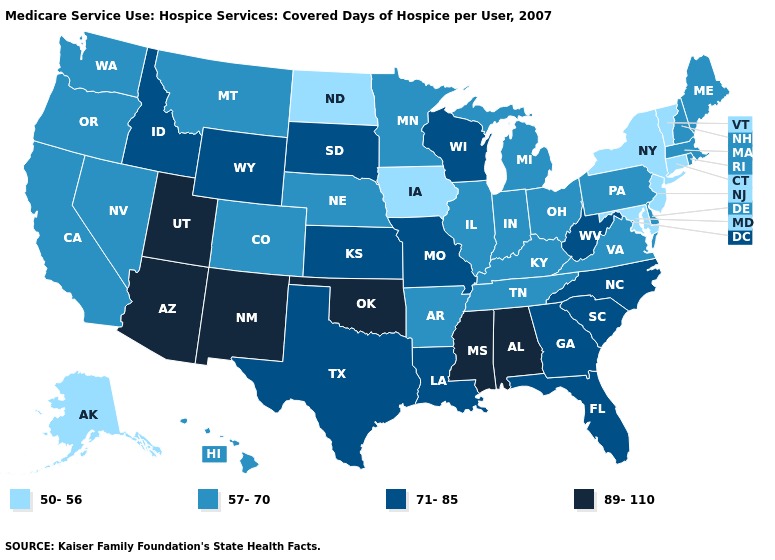Does the first symbol in the legend represent the smallest category?
Give a very brief answer. Yes. Name the states that have a value in the range 50-56?
Answer briefly. Alaska, Connecticut, Iowa, Maryland, New Jersey, New York, North Dakota, Vermont. Which states have the highest value in the USA?
Be succinct. Alabama, Arizona, Mississippi, New Mexico, Oklahoma, Utah. Which states have the highest value in the USA?
Short answer required. Alabama, Arizona, Mississippi, New Mexico, Oklahoma, Utah. What is the lowest value in the USA?
Quick response, please. 50-56. What is the highest value in the West ?
Quick response, please. 89-110. Which states have the lowest value in the West?
Quick response, please. Alaska. What is the value of Illinois?
Short answer required. 57-70. Among the states that border Wyoming , does Utah have the highest value?
Quick response, please. Yes. What is the highest value in states that border Delaware?
Short answer required. 57-70. What is the value of Hawaii?
Quick response, please. 57-70. What is the highest value in the USA?
Concise answer only. 89-110. What is the lowest value in the USA?
Be succinct. 50-56. What is the value of Arizona?
Keep it brief. 89-110. Does Montana have the highest value in the USA?
Be succinct. No. 